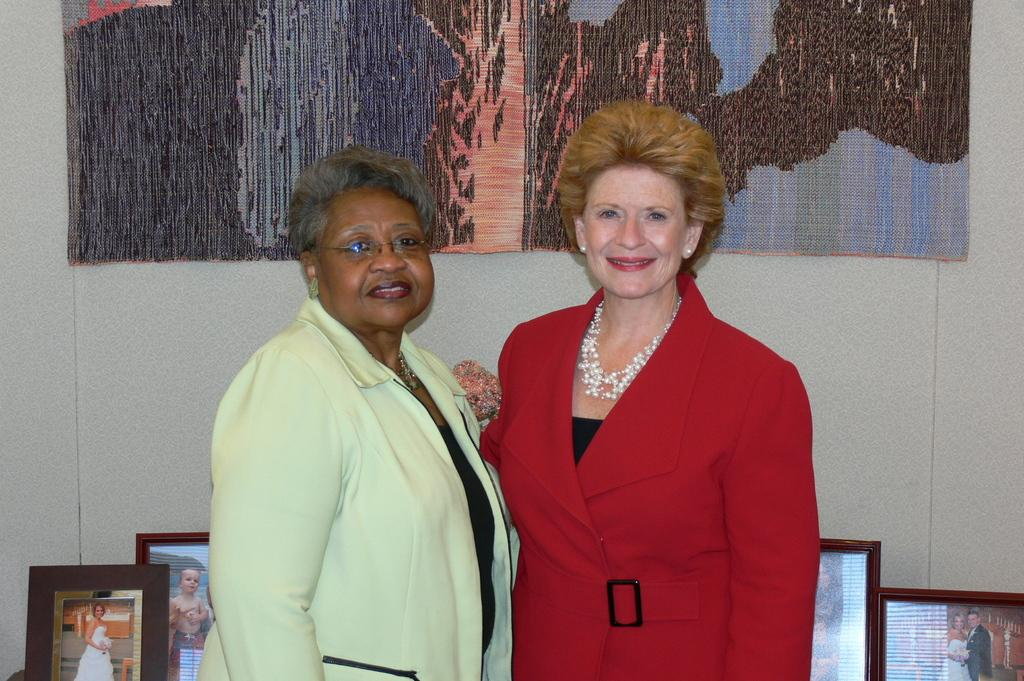How many people are in the image? There are two women in the image. What are the women doing in the image? The women are smiling and watching something. What can be seen in the background of the image? There is a wall and decorative pieces in the background of the image. What is located at the bottom of the image? There are photo frames at the bottom of the image. What type of hat is the woman wearing in the image? There is no hat visible in the image; the women are not wearing any headwear. Can you describe the waves in the image? There are no waves present in the image; it features two women watching something and a background with a wall and decorative pieces. 